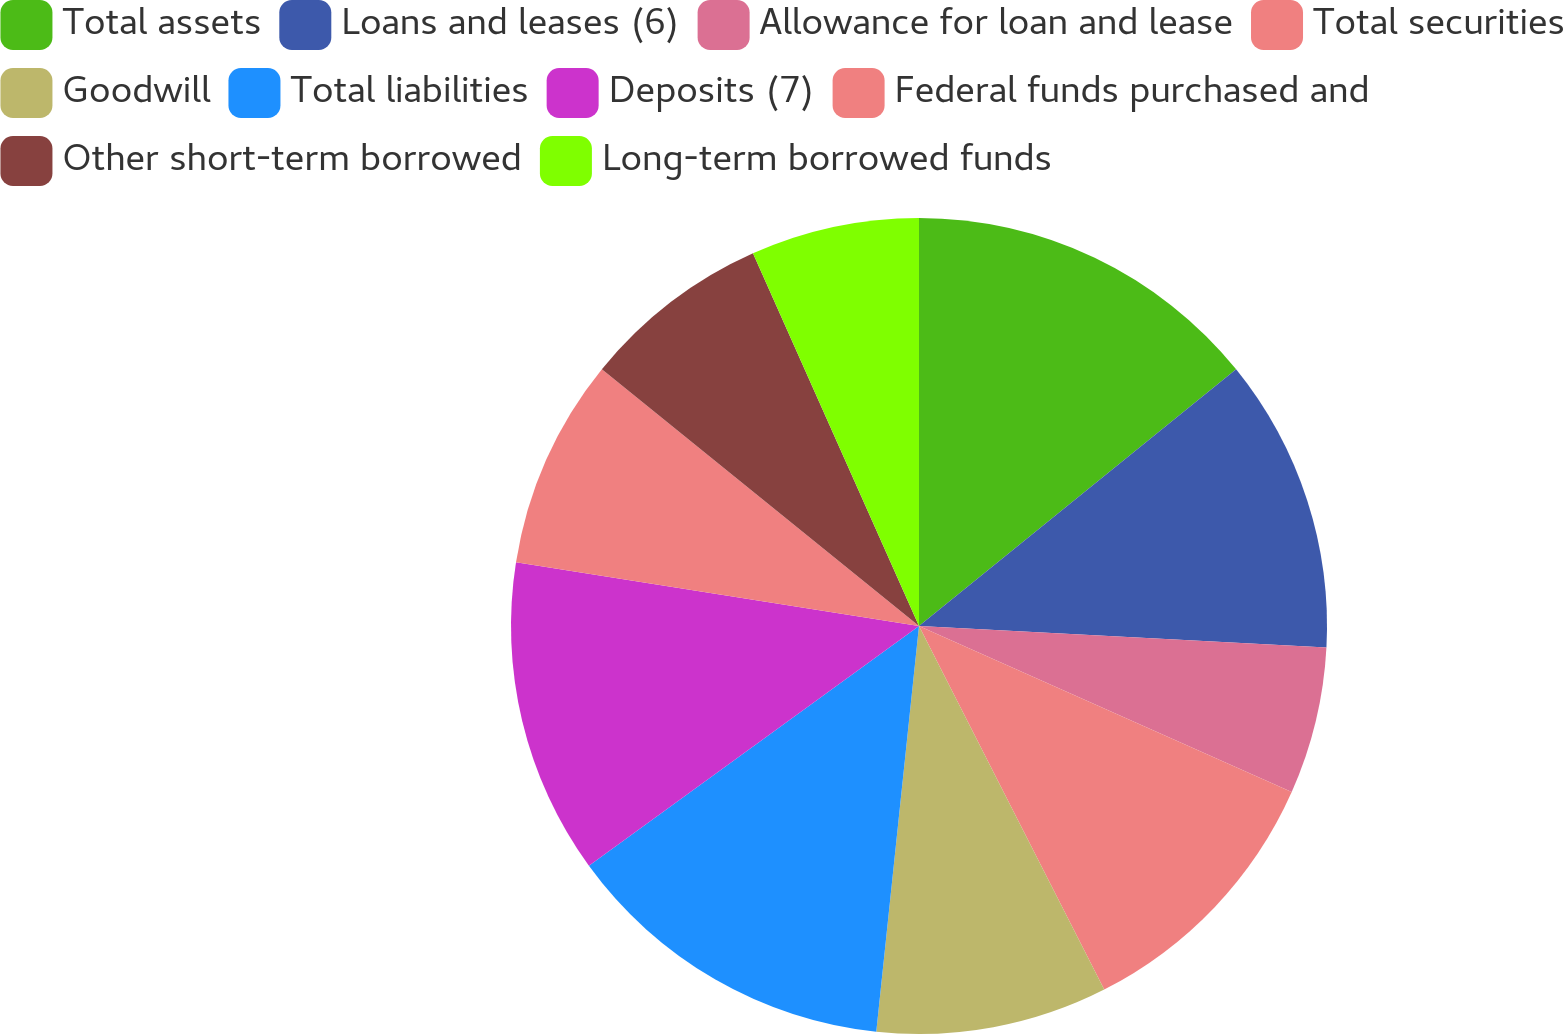Convert chart. <chart><loc_0><loc_0><loc_500><loc_500><pie_chart><fcel>Total assets<fcel>Loans and leases (6)<fcel>Allowance for loan and lease<fcel>Total securities<fcel>Goodwill<fcel>Total liabilities<fcel>Deposits (7)<fcel>Federal funds purchased and<fcel>Other short-term borrowed<fcel>Long-term borrowed funds<nl><fcel>14.17%<fcel>11.67%<fcel>5.83%<fcel>10.83%<fcel>9.17%<fcel>13.33%<fcel>12.5%<fcel>8.33%<fcel>7.5%<fcel>6.67%<nl></chart> 